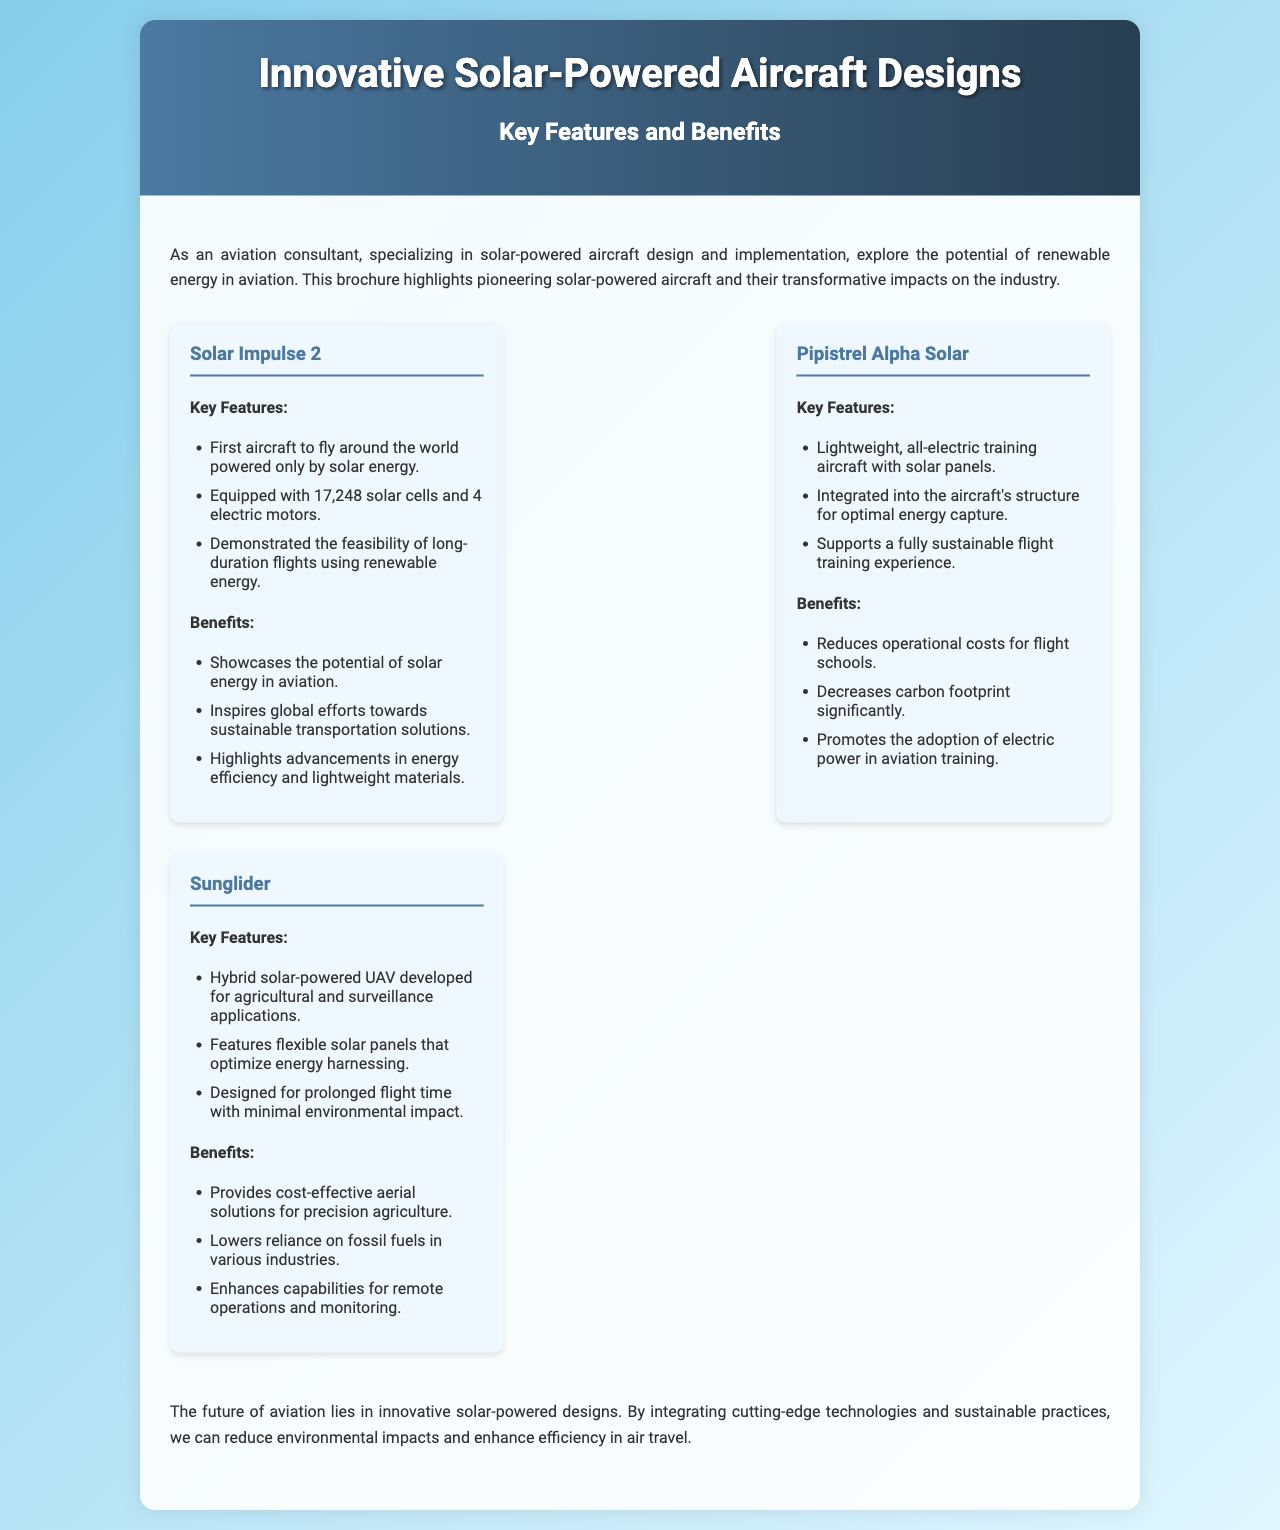What is the first aircraft to fly around the world powered only by solar energy? The document mentions "Solar Impulse 2" as the first aircraft to fly around the world powered only by solar energy.
Answer: Solar Impulse 2 How many solar cells does the Solar Impulse 2 have? According to the document, Solar Impulse 2 is equipped with "17,248 solar cells."
Answer: 17,248 What is a key benefit of the Pipistrel Alpha Solar? The document states that one benefit of the Pipistrel Alpha Solar is that it "reduces operational costs for flight schools."
Answer: Reduces operational costs What type of applications is the Sunglider developed for? The document describes the Sunglider as being developed for "agricultural and surveillance applications."
Answer: Agricultural and surveillance What innovative feature does the Pipistrel Alpha Solar integrate into its structure? The document specifies that Pipistrel Alpha Solar has "solar panels" integrated into the aircraft's structure for optimal energy capture.
Answer: Solar panels How many electric motors does the Solar Impulse 2 have? The document states that Solar Impulse 2 is equipped with "4 electric motors."
Answer: 4 electric motors What future does the conclusion of the document suggest for aviation? The conclusion claims that the future of aviation lies in "innovative solar-powered designs."
Answer: Innovative solar-powered designs What is the main purpose of the brochure? The introduction indicates that the brochure aims to explore "the potential of renewable energy in aviation."
Answer: Potential of renewable energy in aviation What impact does the Sunglider have on fossil fuel reliance? The document mentions that the Sunglider "lowers reliance on fossil fuels in various industries."
Answer: Lowers reliance on fossil fuels 